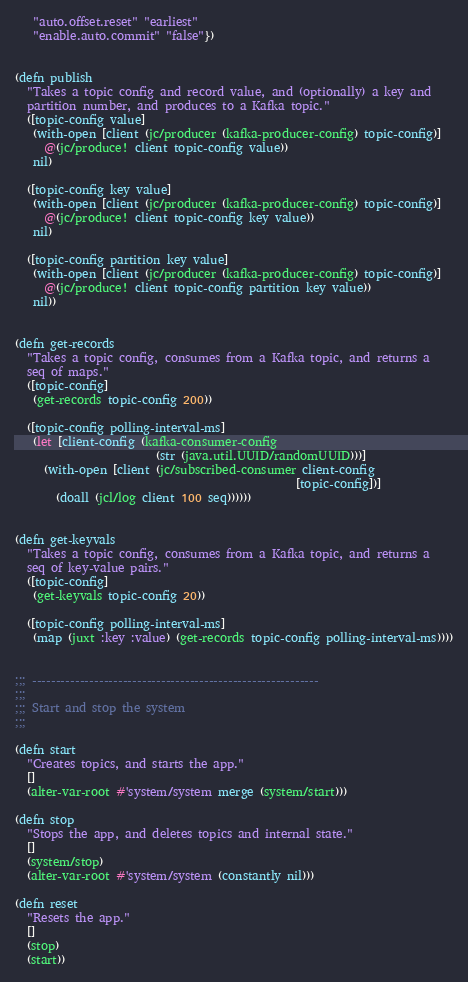<code> <loc_0><loc_0><loc_500><loc_500><_Clojure_>   "auto.offset.reset" "earliest"
   "enable.auto.commit" "false"})


(defn publish
  "Takes a topic config and record value, and (optionally) a key and
  partition number, and produces to a Kafka topic."
  ([topic-config value]
   (with-open [client (jc/producer (kafka-producer-config) topic-config)]
     @(jc/produce! client topic-config value))
   nil)

  ([topic-config key value]
   (with-open [client (jc/producer (kafka-producer-config) topic-config)]
     @(jc/produce! client topic-config key value))
   nil)

  ([topic-config partition key value]
   (with-open [client (jc/producer (kafka-producer-config) topic-config)]
     @(jc/produce! client topic-config partition key value))
   nil))


(defn get-records
  "Takes a topic config, consumes from a Kafka topic, and returns a
  seq of maps."
  ([topic-config]
   (get-records topic-config 200))

  ([topic-config polling-interval-ms]
   (let [client-config (kafka-consumer-config
                        (str (java.util.UUID/randomUUID)))]
     (with-open [client (jc/subscribed-consumer client-config
                                                [topic-config])]
       (doall (jcl/log client 100 seq))))))


(defn get-keyvals
  "Takes a topic config, consumes from a Kafka topic, and returns a
  seq of key-value pairs."
  ([topic-config]
   (get-keyvals topic-config 20))

  ([topic-config polling-interval-ms]
   (map (juxt :key :value) (get-records topic-config polling-interval-ms))))


;;; ------------------------------------------------------------
;;;
;;; Start and stop the system
;;;

(defn start
  "Creates topics, and starts the app."
  []
  (alter-var-root #'system/system merge (system/start)))

(defn stop
  "Stops the app, and deletes topics and internal state."
  []
  (system/stop)
  (alter-var-root #'system/system (constantly nil)))

(defn reset
  "Resets the app."
  []
  (stop)
  (start))
</code> 